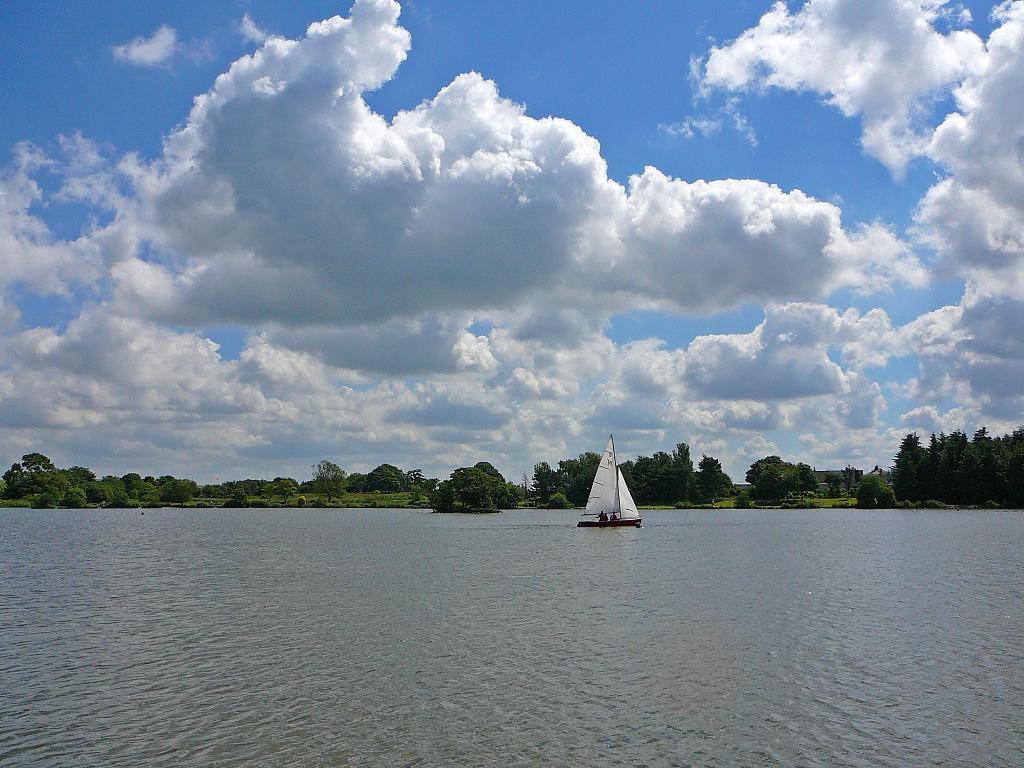Describe this image in one or two sentences. In the picture we can see the water surface with a boat and some people sitting in it and far away from it, we can see many trees and behind it we can see the sky with clouds. 